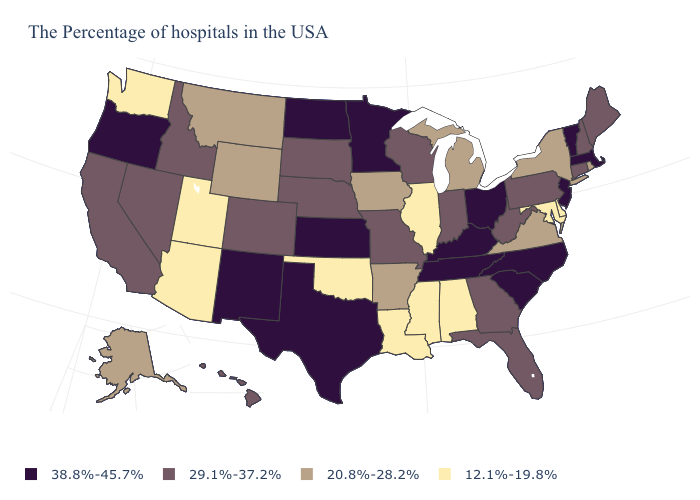Does Texas have a higher value than North Carolina?
Concise answer only. No. Name the states that have a value in the range 38.8%-45.7%?
Give a very brief answer. Massachusetts, Vermont, New Jersey, North Carolina, South Carolina, Ohio, Kentucky, Tennessee, Minnesota, Kansas, Texas, North Dakota, New Mexico, Oregon. Name the states that have a value in the range 20.8%-28.2%?
Be succinct. Rhode Island, New York, Virginia, Michigan, Arkansas, Iowa, Wyoming, Montana, Alaska. What is the value of Arkansas?
Answer briefly. 20.8%-28.2%. What is the value of New Mexico?
Quick response, please. 38.8%-45.7%. Name the states that have a value in the range 38.8%-45.7%?
Write a very short answer. Massachusetts, Vermont, New Jersey, North Carolina, South Carolina, Ohio, Kentucky, Tennessee, Minnesota, Kansas, Texas, North Dakota, New Mexico, Oregon. What is the value of Oregon?
Quick response, please. 38.8%-45.7%. What is the value of Missouri?
Give a very brief answer. 29.1%-37.2%. Does Washington have the lowest value in the USA?
Write a very short answer. Yes. Which states have the lowest value in the USA?
Be succinct. Delaware, Maryland, Alabama, Illinois, Mississippi, Louisiana, Oklahoma, Utah, Arizona, Washington. Does North Carolina have the lowest value in the USA?
Short answer required. No. Is the legend a continuous bar?
Quick response, please. No. Among the states that border Michigan , does Wisconsin have the highest value?
Answer briefly. No. What is the value of Kentucky?
Give a very brief answer. 38.8%-45.7%. What is the value of Kentucky?
Give a very brief answer. 38.8%-45.7%. 